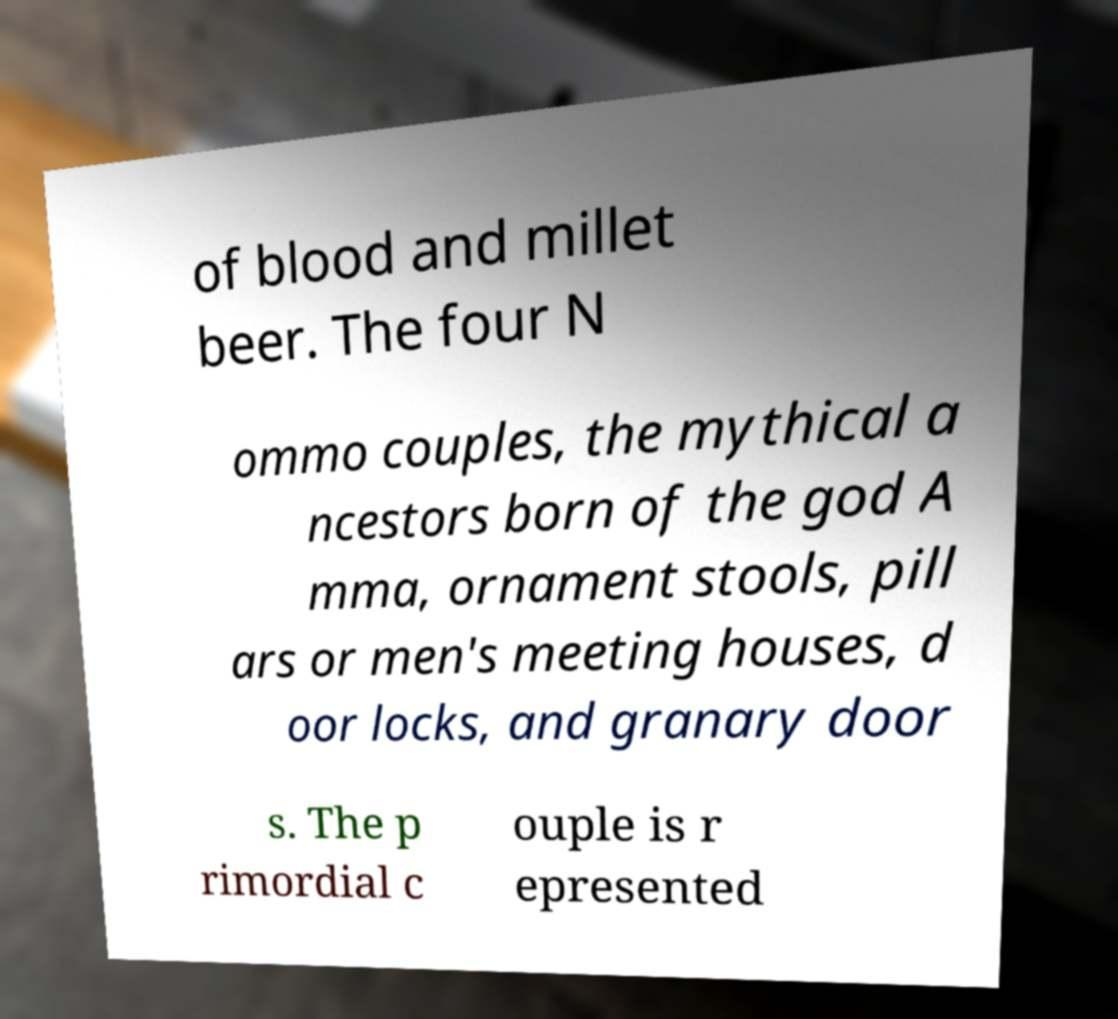Can you read and provide the text displayed in the image?This photo seems to have some interesting text. Can you extract and type it out for me? of blood and millet beer. The four N ommo couples, the mythical a ncestors born of the god A mma, ornament stools, pill ars or men's meeting houses, d oor locks, and granary door s. The p rimordial c ouple is r epresented 